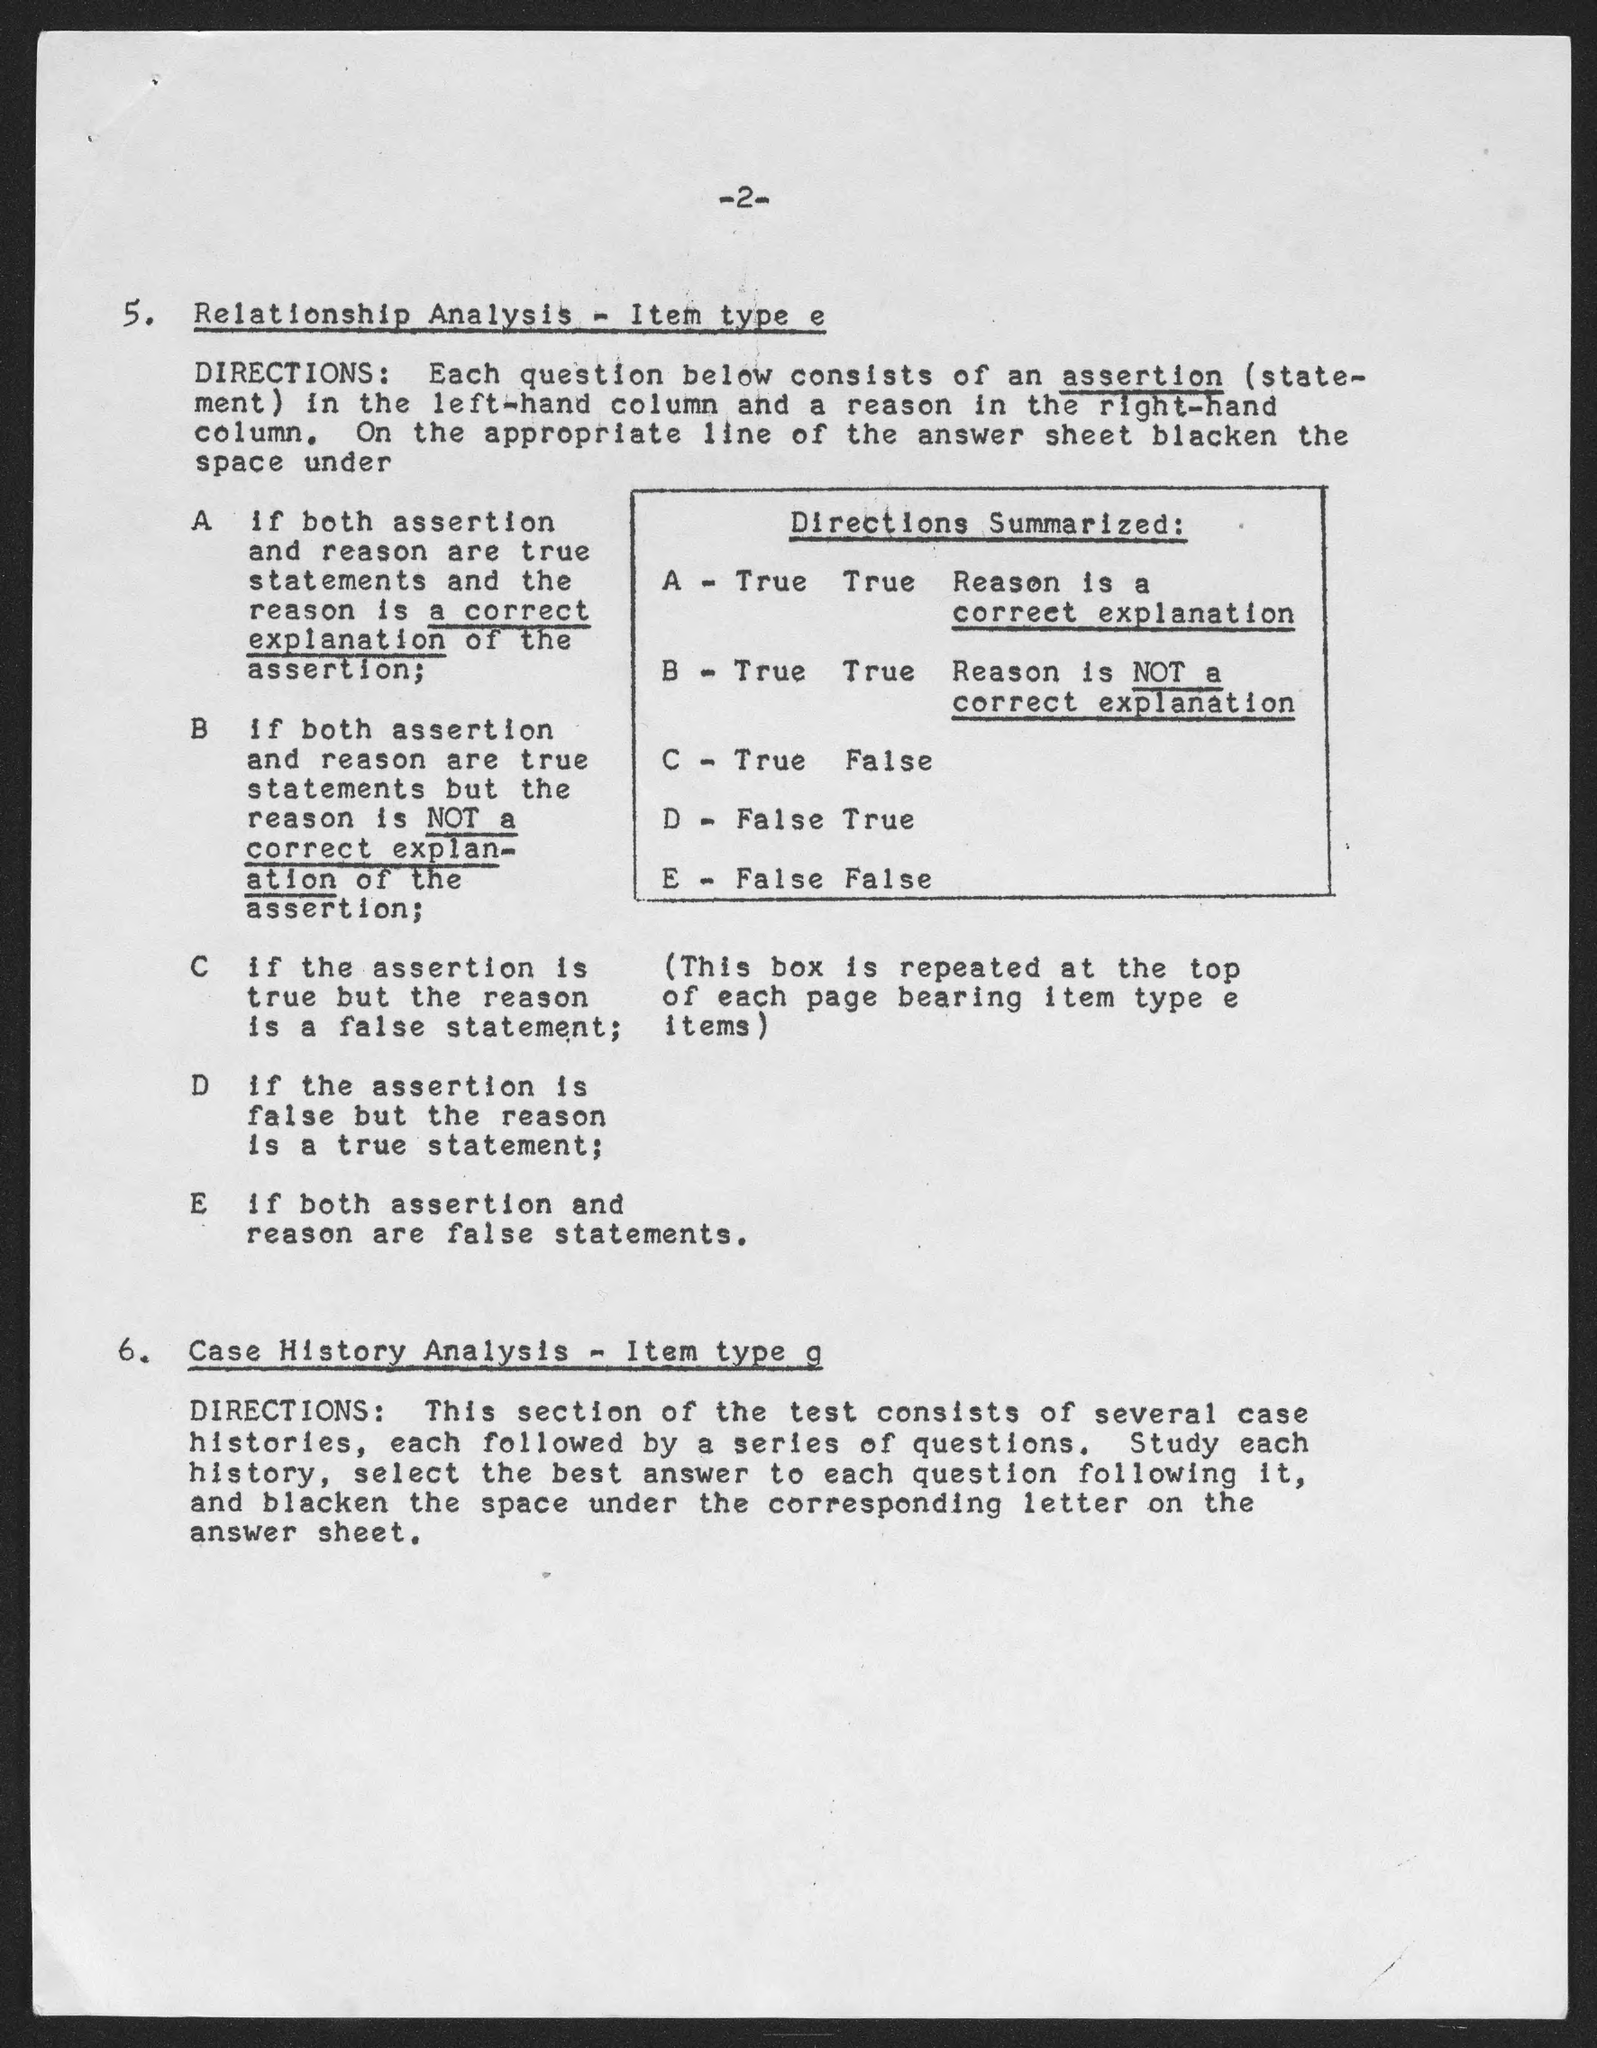What is the page number?
Ensure brevity in your answer.  -2-. What is the first title in the document?
Provide a succinct answer. Relationship analysis - item type e. 